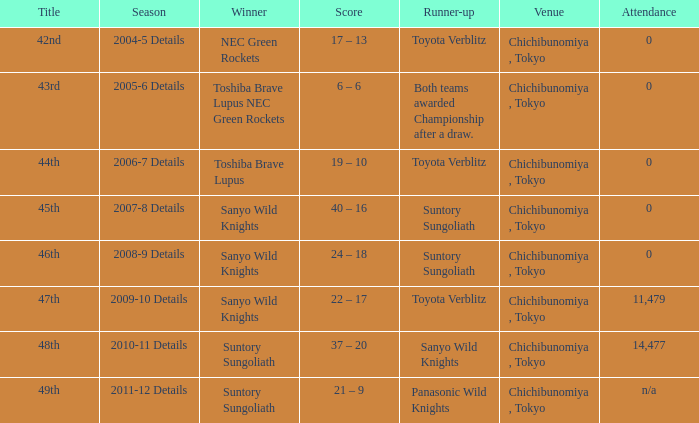What is the Score when the winner was suntory sungoliath, and the number attendance was n/a? 21 – 9. 